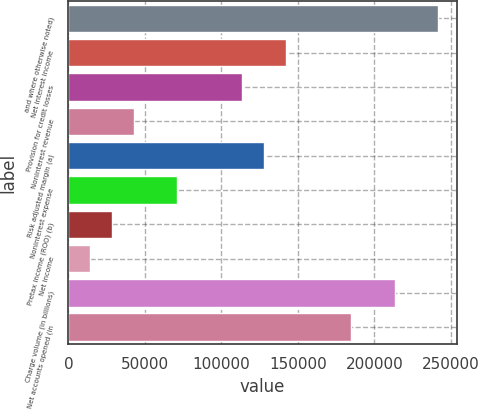Convert chart to OTSL. <chart><loc_0><loc_0><loc_500><loc_500><bar_chart><fcel>and where otherwise noted)<fcel>Net interest income<fcel>Provision for credit losses<fcel>Noninterest revenue<fcel>Risk adjusted margin (a)<fcel>Noninterest expense<fcel>Pretax income (ROO) (b)<fcel>Net income<fcel>Charge volume (in billions)<fcel>Net accounts opened (in<nl><fcel>241850<fcel>142265<fcel>113812<fcel>42680.4<fcel>128039<fcel>71133.1<fcel>28454<fcel>14227.6<fcel>213397<fcel>184944<nl></chart> 